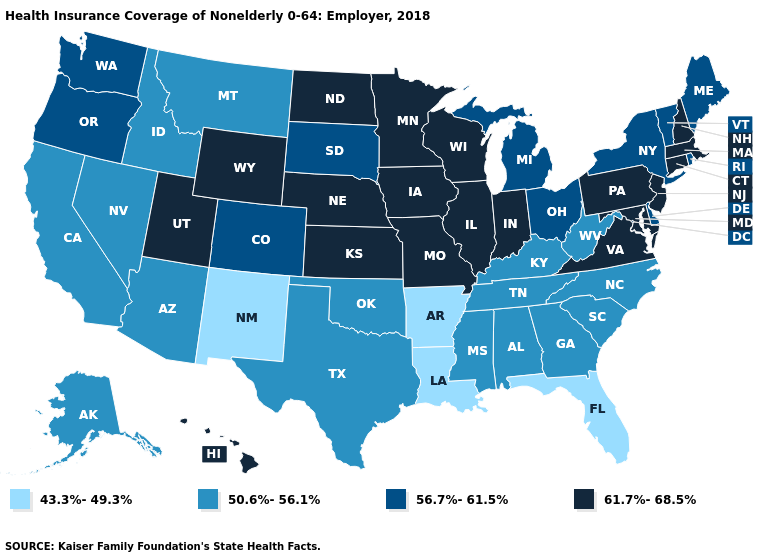What is the value of Montana?
Short answer required. 50.6%-56.1%. Does the first symbol in the legend represent the smallest category?
Be succinct. Yes. Name the states that have a value in the range 61.7%-68.5%?
Write a very short answer. Connecticut, Hawaii, Illinois, Indiana, Iowa, Kansas, Maryland, Massachusetts, Minnesota, Missouri, Nebraska, New Hampshire, New Jersey, North Dakota, Pennsylvania, Utah, Virginia, Wisconsin, Wyoming. Among the states that border Arkansas , which have the highest value?
Write a very short answer. Missouri. Does Vermont have the highest value in the Northeast?
Answer briefly. No. What is the highest value in states that border Oregon?
Answer briefly. 56.7%-61.5%. Does Arizona have a lower value than California?
Give a very brief answer. No. Does Idaho have the same value as Ohio?
Quick response, please. No. What is the value of Montana?
Be succinct. 50.6%-56.1%. Which states hav the highest value in the Northeast?
Keep it brief. Connecticut, Massachusetts, New Hampshire, New Jersey, Pennsylvania. What is the value of Maryland?
Short answer required. 61.7%-68.5%. Name the states that have a value in the range 61.7%-68.5%?
Give a very brief answer. Connecticut, Hawaii, Illinois, Indiana, Iowa, Kansas, Maryland, Massachusetts, Minnesota, Missouri, Nebraska, New Hampshire, New Jersey, North Dakota, Pennsylvania, Utah, Virginia, Wisconsin, Wyoming. What is the value of Virginia?
Answer briefly. 61.7%-68.5%. What is the value of Arkansas?
Be succinct. 43.3%-49.3%. Does the first symbol in the legend represent the smallest category?
Short answer required. Yes. 